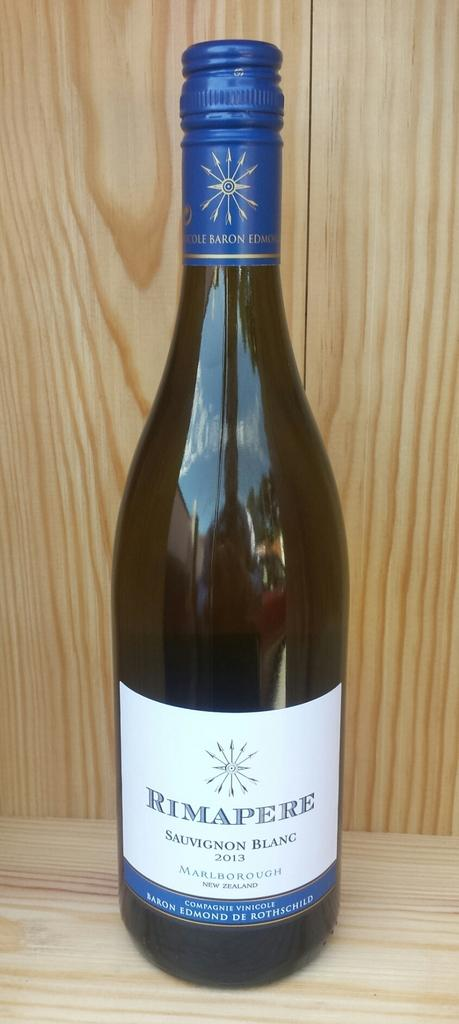Provide a one-sentence caption for the provided image. An unopened bottle of sauvignon blanc wine with blue foil. 